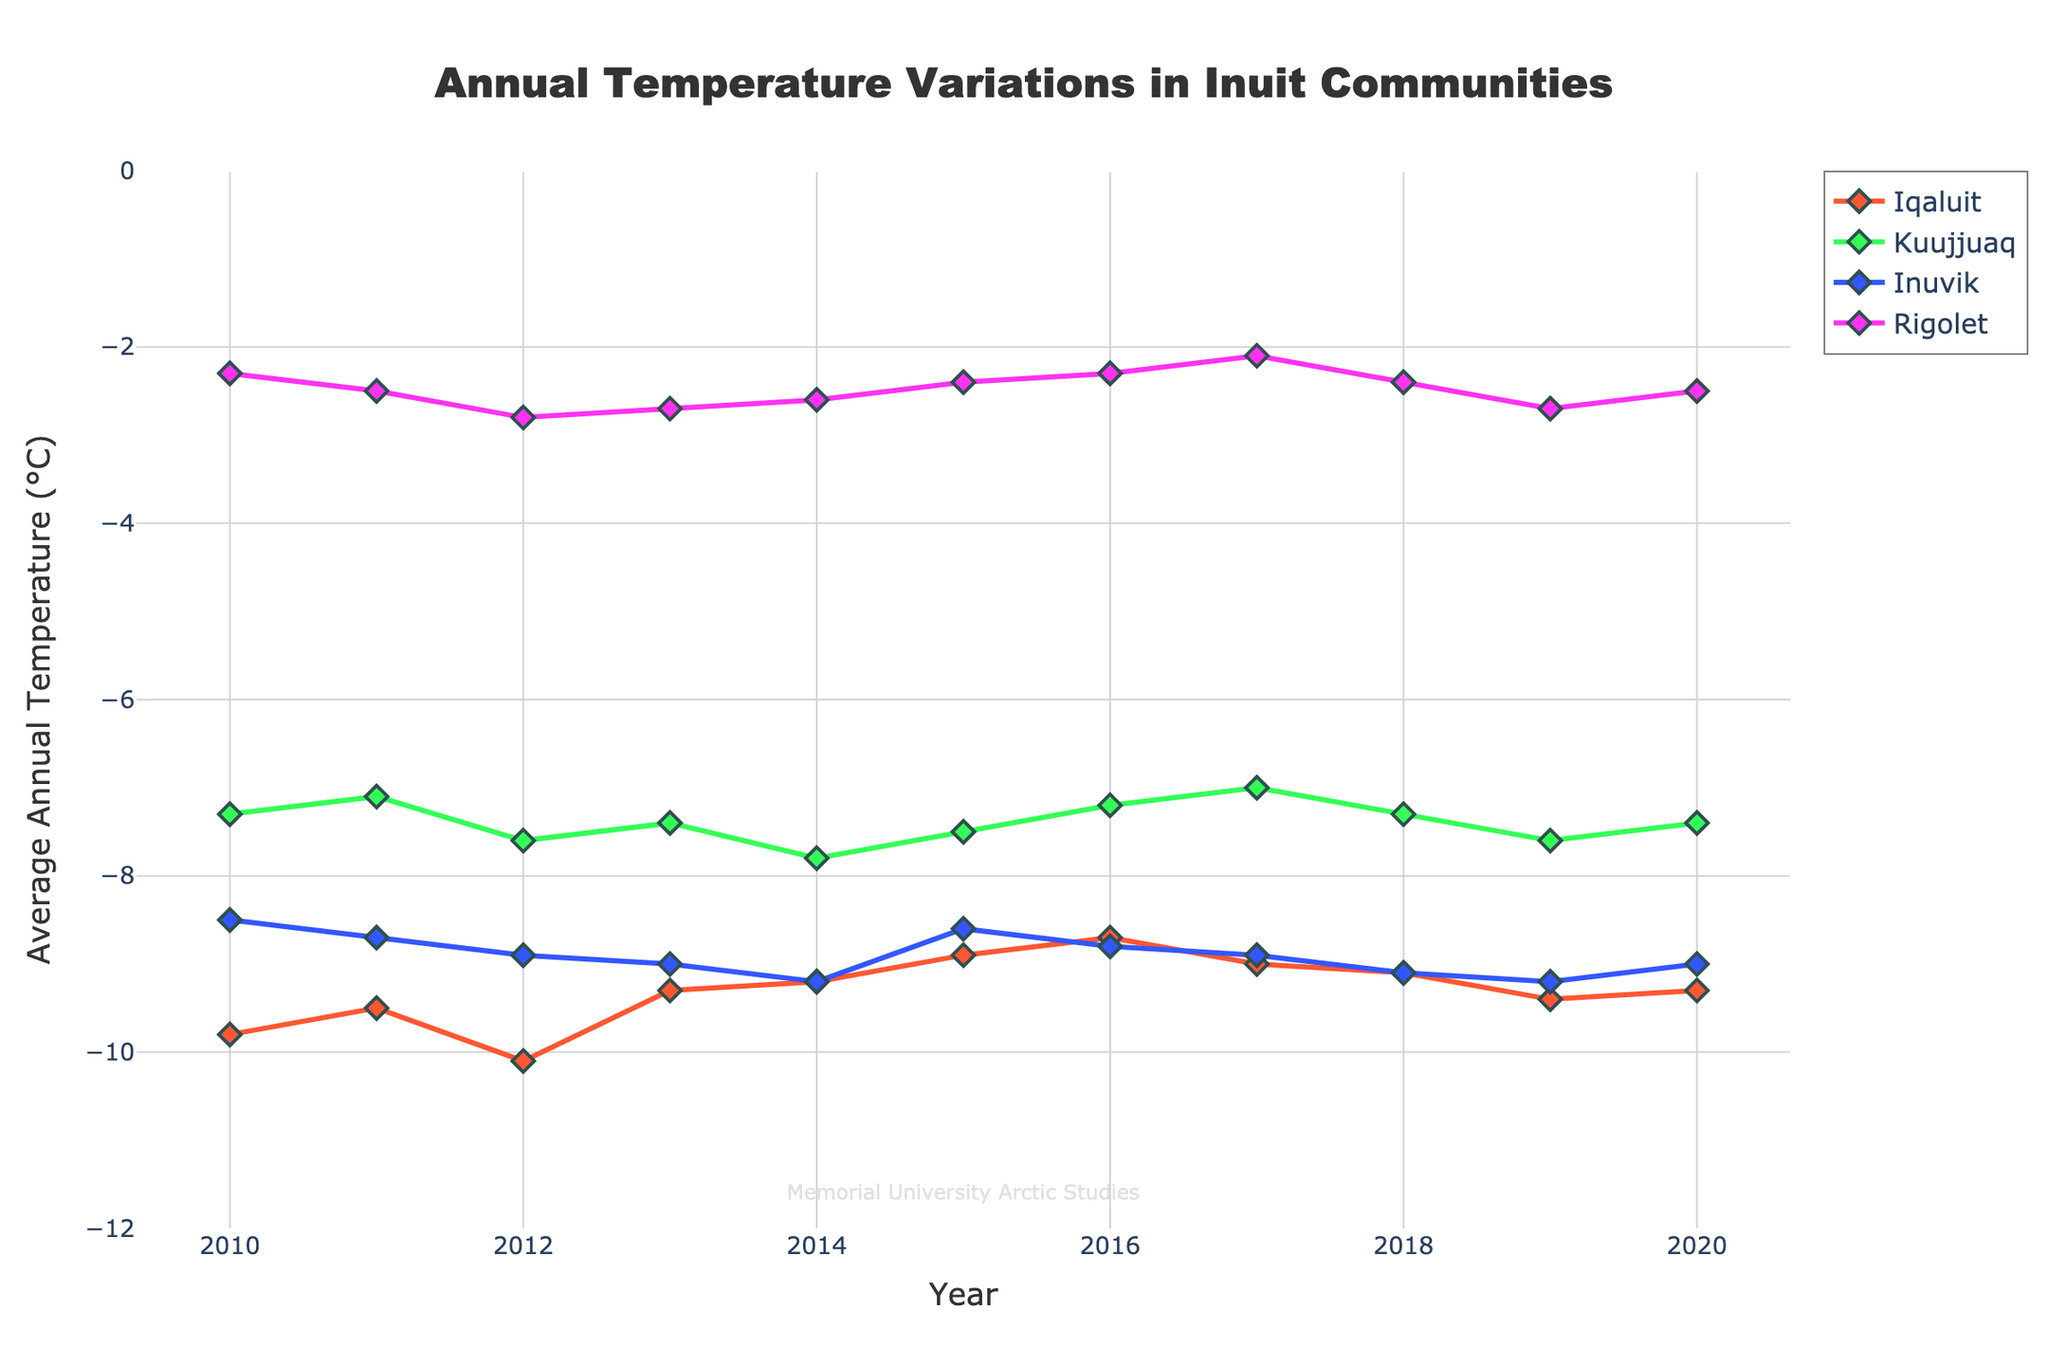What is the title of the figure? The title is typically found at the top of the figure and is usually larger than other text. By looking at the top center, we see "Annual Temperature Variations in Inuit Communities".
Answer: Annual Temperature Variations in Inuit Communities How many communities are represented in the figure? Each community has a distinct colored line, and there are four different colors, each line corresponds to one community, which can be easily counted.
Answer: Four What years does the figure cover? The x-axis of the plot represents the years. By examining it, we see the first point starts at 2010 and the last point ends at 2020.
Answer: 2010 to 2020 Which community has the warmest average annual temperature in 2015? To find this, locate the points on the graph that correspond to 2015 on the x-axis. The y-coordinate of each point represents the temperature. Compare these y-values to see which is highest. Rigolet has the warmest.
Answer: Rigolet Between which years did Iqaluit experience a decrease in average annual temperature? Locate the series for Iqaluit and observe the trend from year to year. Note the segments where the temperature value is descending. From 2015 to 2016 and 2018 to 2019, Iqaluit experienced a decrease.
Answer: 2015 to 2016, 2018 to 2019 Which community shows the most overall stability in its temperature trend? Stability means less fluctuation or change. Observe each community's line trend and determine which is closest to a horizontal line. Rigolet shows almost no fluctuation compared to others.
Answer: Rigolet What's the average annual temperature of Kuujjuaq in 2016 and 2017? Find the points for Kuujjuaq at 2016 and 2017, which are -7.2 and -7.0 respectively. The average is calculated by summing these two values and dividing by 2. (-7.2 + -7.0)/2 = -7.1.
Answer: -7.1 Did Inuvik have a hotter or colder average annual temperature in 2013 compared to 2014? Compare the points for Inuvik at the years 2013 and 2014. In 2013, Inuvik was colder at -9.0°C compared to -9.2°C in 2014.
Answer: Hotter in 2013 Which year did Rigolet experience its lowest average annual temperature? Observe the trend line for Rigolet and identify the lowest point. In 2012, it was -2.8°C which is its lowest temperature.
Answer: 2012 How does the temperature variation trend of Kuujjuaq compare between 2010 and 2020? Observe the Kuujjuaq line from 2010 to 2020, noting any significant increases or decreases. Overall, Kuujjuaq's temperature shows minor fluctuations, indicating a relatively stable trend.
Answer: Relatively stable 